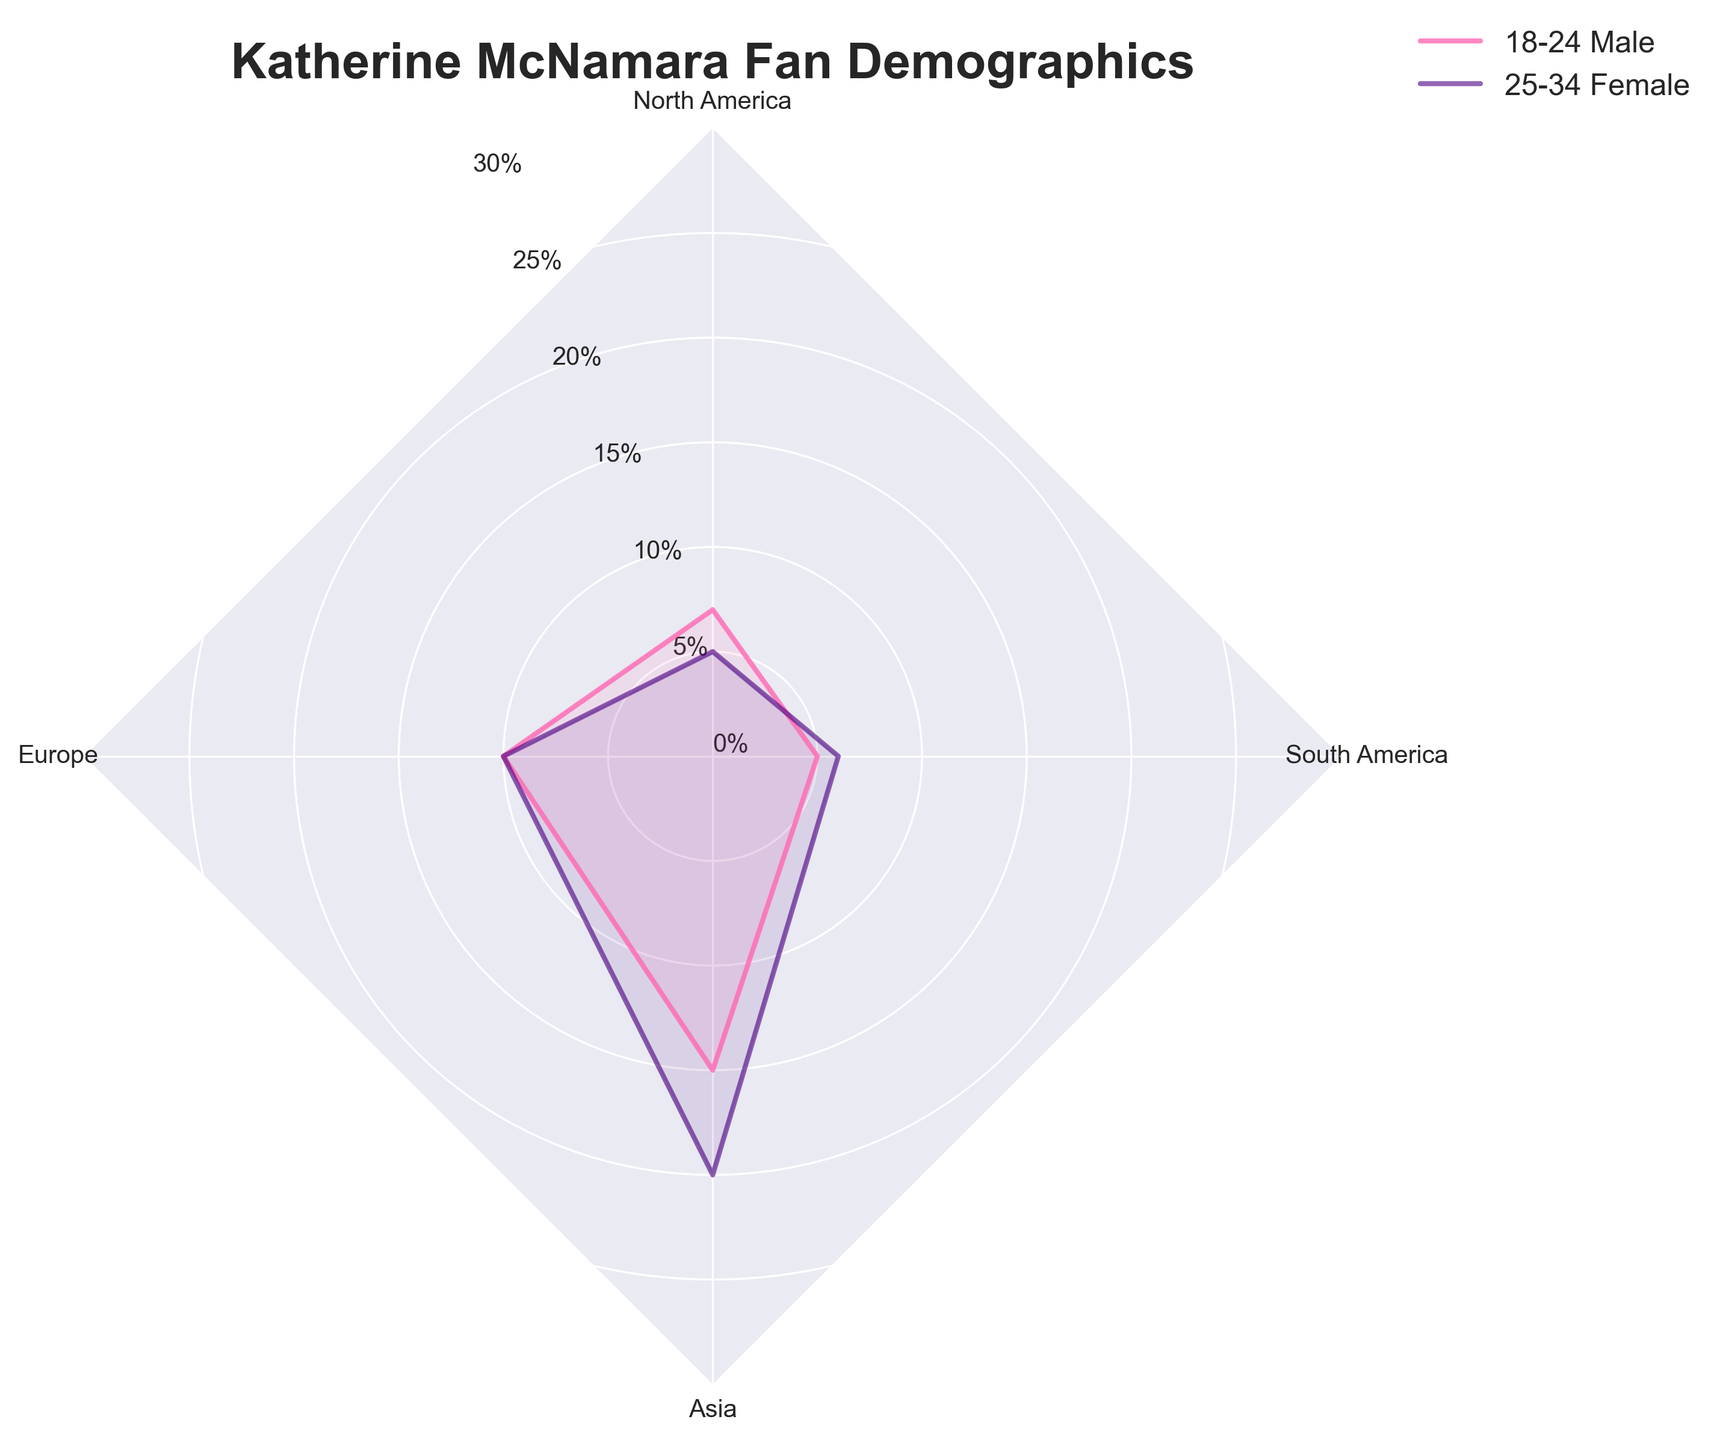What is the title of the radar chart? The title of the radar chart is positioned at the top and usually describes the main focus of the chart. It reads "Katherine McNamara Fan Demographics".
Answer: Katherine McNamara Fan Demographics Which age group and gender combination has the highest percentage of fans in North America? By observing the radar chart, we can identify the data points for North America and compare their values. The highest percentage for North America is at 25%. This is associated with the 18-24 Female group.
Answer: 18-24 Female What is the range of percentage values plotted on the radar chart? The radial axis of the radar chart is labeled from the center outward, with percentage values clearly marked. The range starts at 0% and goes up to 30%.
Answer: 0% to 30% Among fans aged 25-34, which gender has a higher percentage in South America? By comparing the data points for 25-34 Male and 25-34 Female in South America, we can see that the percentage for females is higher at 6%, compared to males at 4%.
Answer: Female What are the colors used to represent different age and gender groups? The radar chart uses different colors to distinguish between groups: '#FF69B4' for a group (likely 18-24 Male), '#4B0082' for another group (likely 18-24 Female), and '#00CED1' for another group (likely 25-34 Male/Female). The exact mapping from colors to groups can be verified from the legend.
Answer: Pink, Indigo, Medium Turquoise Does the 18-24 Male group have any geographic location with a percentage value below 10%? By observing the radar chart, we check the values for each geographic location for the 18-24 Male group. All values below 10% are in Asia (7%) and South America (5%).
Answer: Yes Which geographic location has the lowest percentage of fans aged 18-24 Female? Reviewing the values on the radar chart for the 18-24 Female group across all geographic locations, the lowest percentage is in Asia at 8%.
Answer: Asia Comparing genders in Europe for the 18-24 age group, which gender has a higher percentage of fans? We see that in Europe, the 18-24 Female group has a higher percentage (15%) compared to the 18-24 Male group (10%).
Answer: Female What is the total percentage of fans in North America across all age groups and genders? Adding the values for North America: 15% (18-24 Male) + 25% (18-24 Female) + 10% (25-34 Male) + 20% (25-34 Female) = 70%.
Answer: 70% Based on the data, which demographic (age and gender combination) is consistently lower in percentage across all geographic locations? To determine the lowest consistent percentages, we compare each age and gender group across all locations. The 25-34 Male group has consistently low percentages: North America (10%), Europe (5%), Asia (3%), and South America (4%).
Answer: 25-34 Male 